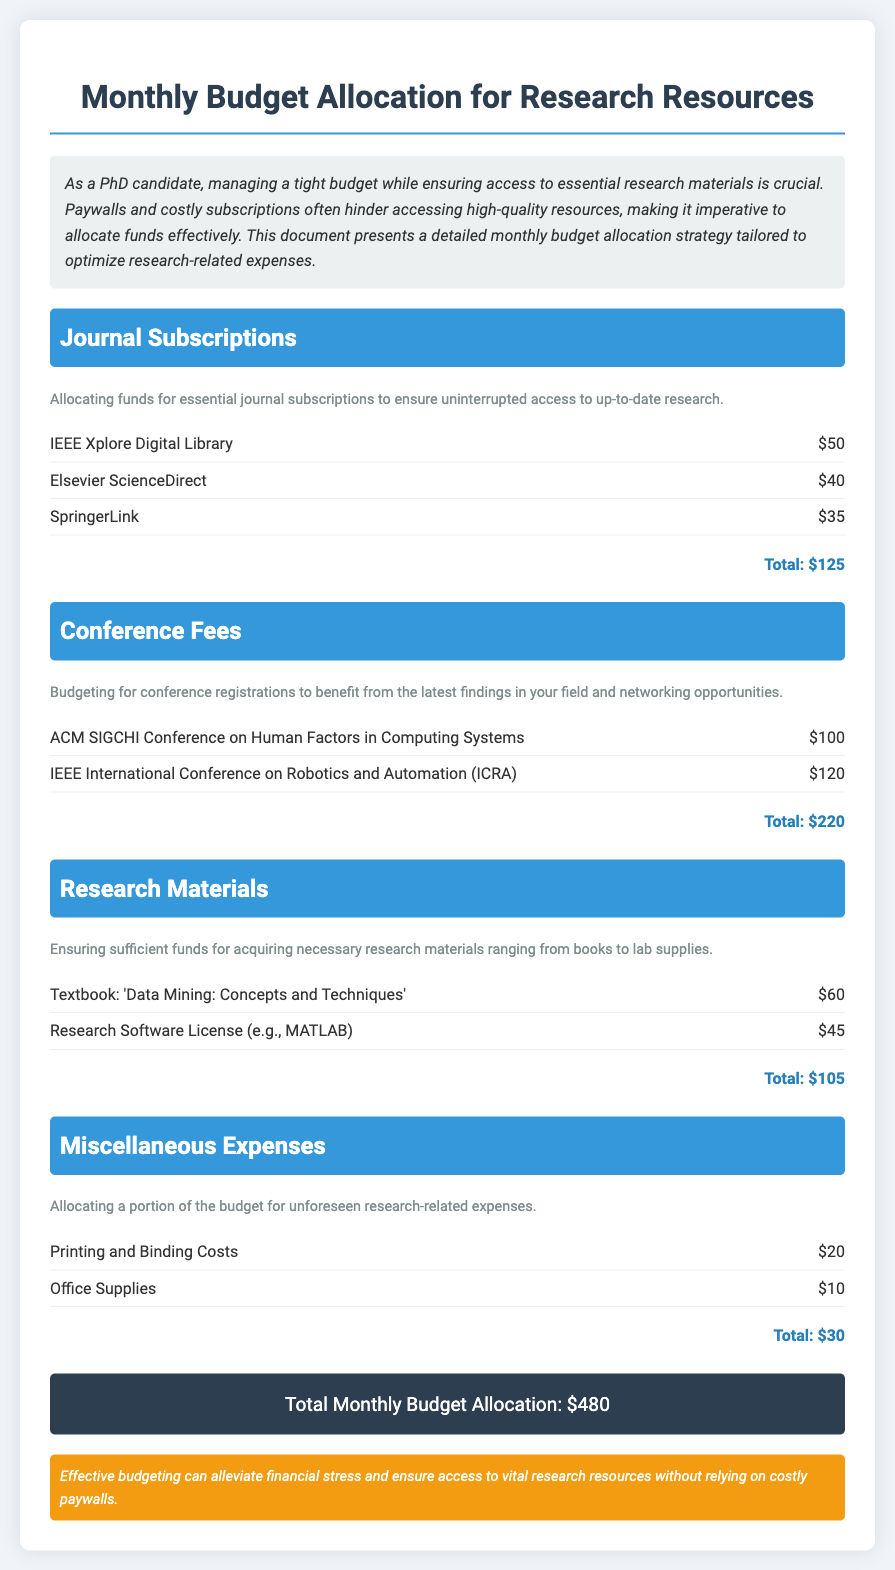What is the title of the document? The title is indicated prominently at the top of the document.
Answer: Monthly Budget Allocation for Research Resources How much is allocated for journal subscriptions? The allocation for journal subscriptions can be found under that specific section.
Answer: $125 What are the two conferences listed in the budget? The conferences can be found in the section dedicated to conference fees.
Answer: ACM SIGCHI Conference on Human Factors in Computing Systems, IEEE International Conference on Robotics and Automation (ICRA) What is the total monthly budget allocation? The total is summarized at the end of the document, aggregating all sections.
Answer: $480 What percentage of the total budget is allocated for conference fees? This requires calculating the percentage based on the total budget and the conference fees listed.
Answer: 45.83% What is the cost of the textbook listed under research materials? The cost of the textbook is specified in the research materials section.
Answer: $60 What type of products fall under miscellaneous expenses? The miscellaneous expenses section describes these products.
Answer: Printing and Binding Costs, Office Supplies What is the section description for journal subscriptions? This description gives insight into the purpose of the allocated funds.
Answer: Allocating funds for essential journal subscriptions to ensure uninterrupted access to up-to-date research 